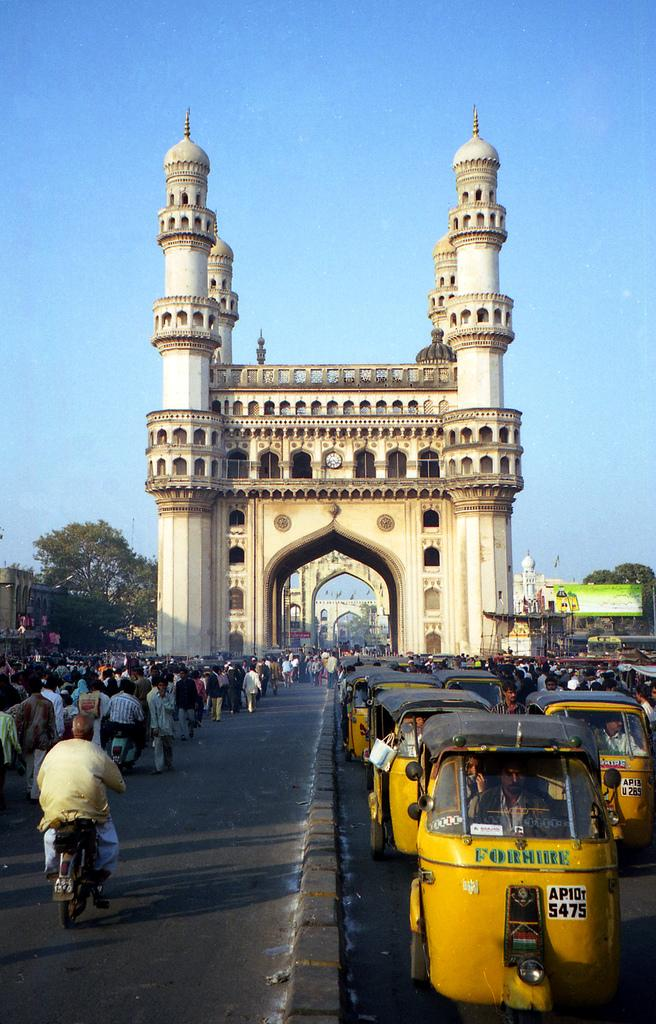<image>
Render a clear and concise summary of the photo. A castle-like structure with many people and taxi's that are for hire, with taxi 5475 in front. 